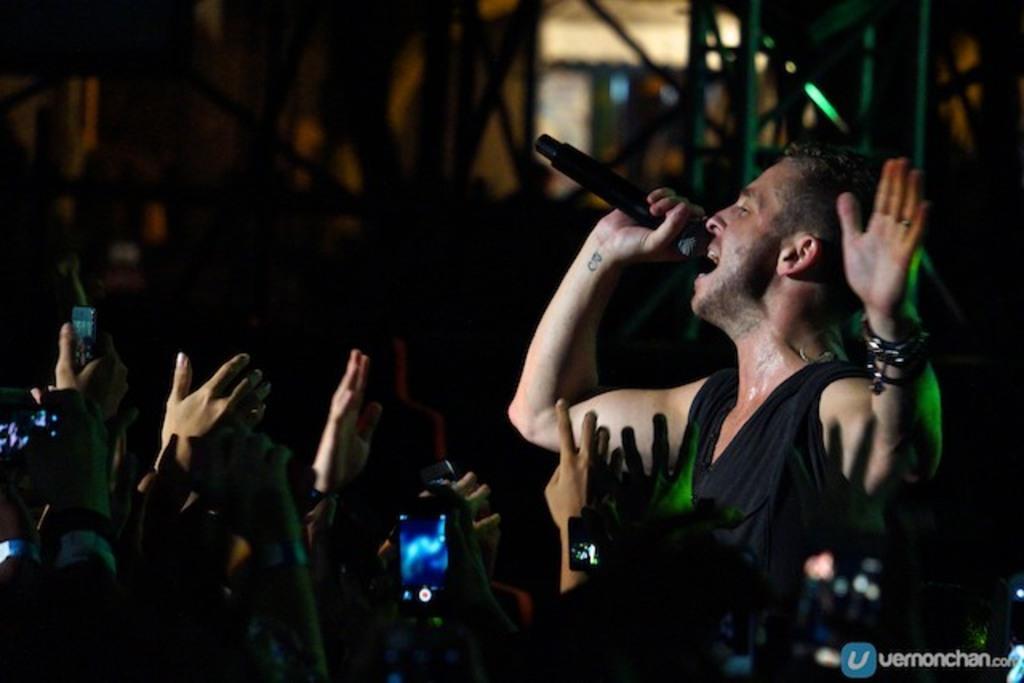Could you give a brief overview of what you see in this image? As we can see in the image there are few people here and there and the man over here is holding mic and singing a song. 